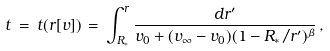Convert formula to latex. <formula><loc_0><loc_0><loc_500><loc_500>t \, = \, t ( r [ v ] ) \, = \, \int _ { R _ { \ast } } ^ { r } \frac { d r ^ { \prime } } { v _ { 0 } + ( v _ { \infty } - v _ { 0 } ) ( 1 - R _ { \ast } / r ^ { \prime } ) ^ { \beta } } \, ,</formula> 